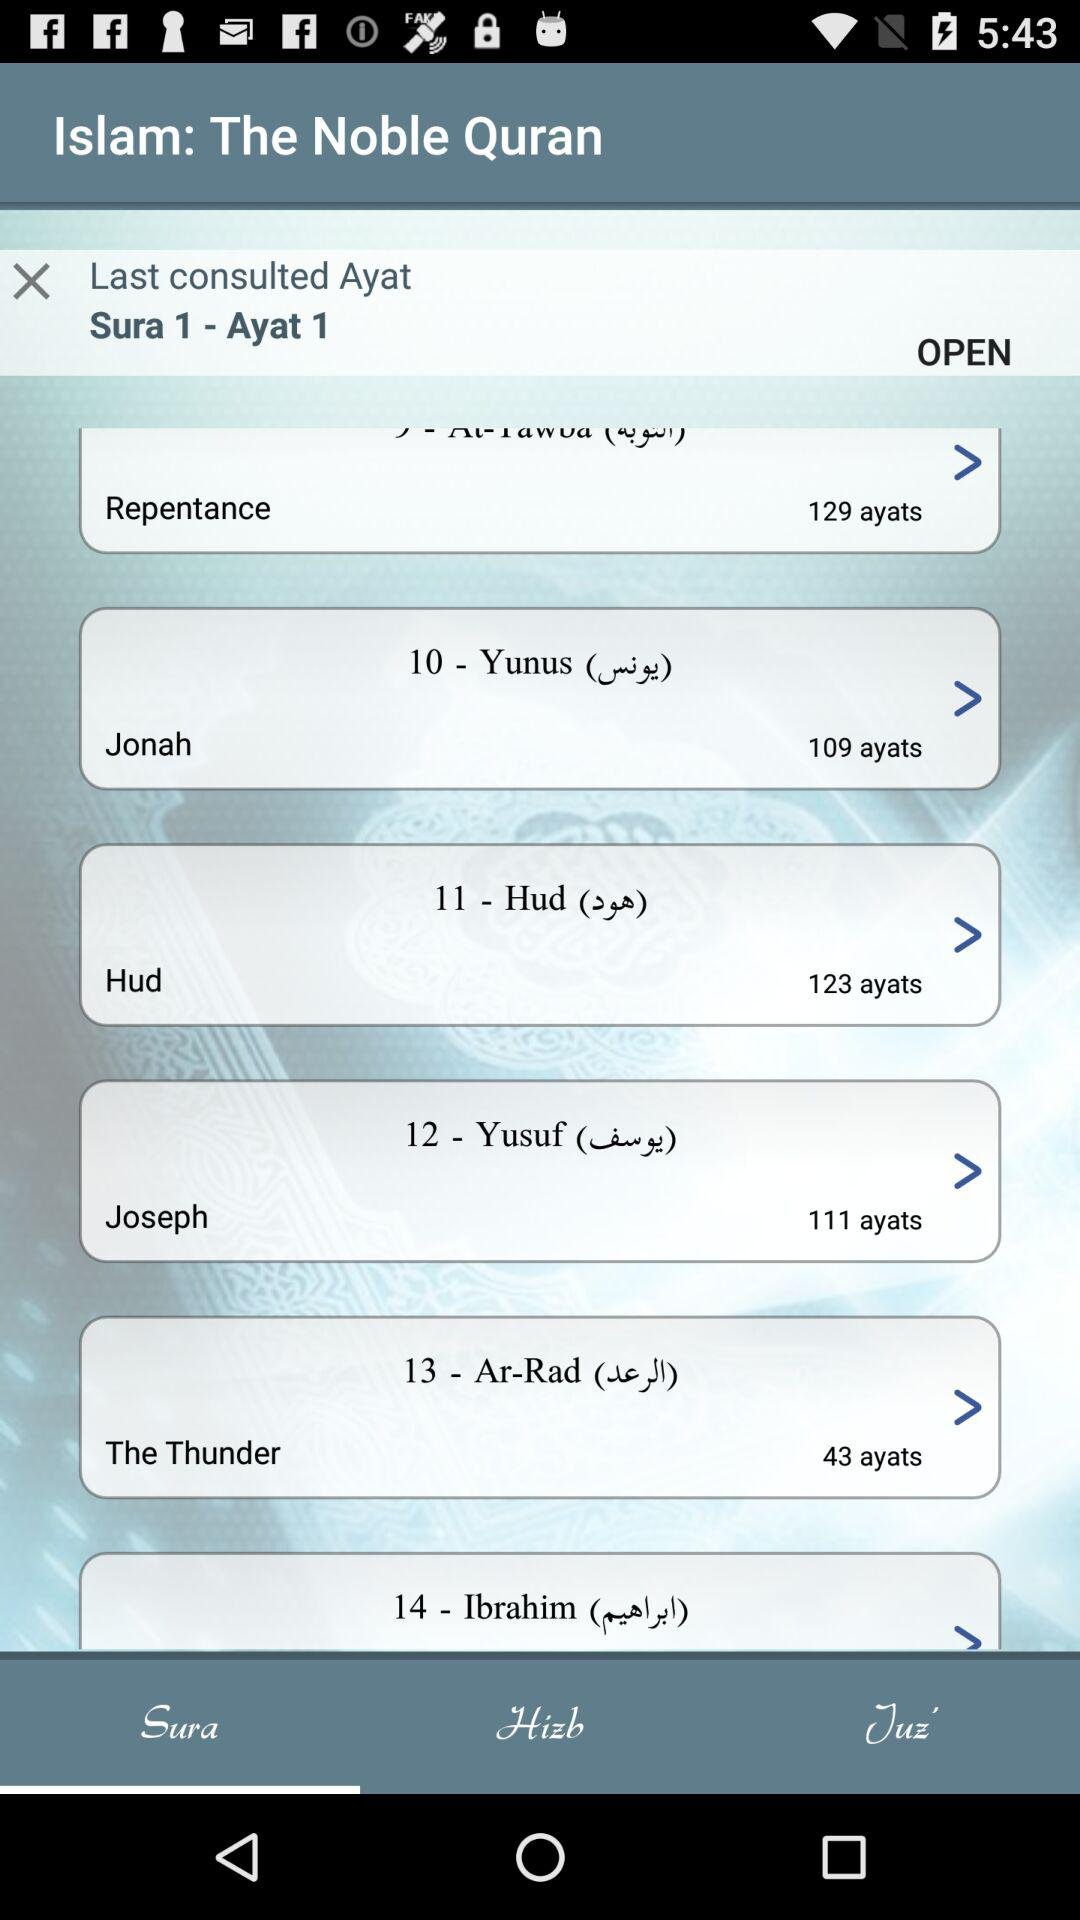What is the number of ayats in "The Thunder"? The number of ayats is 43. 